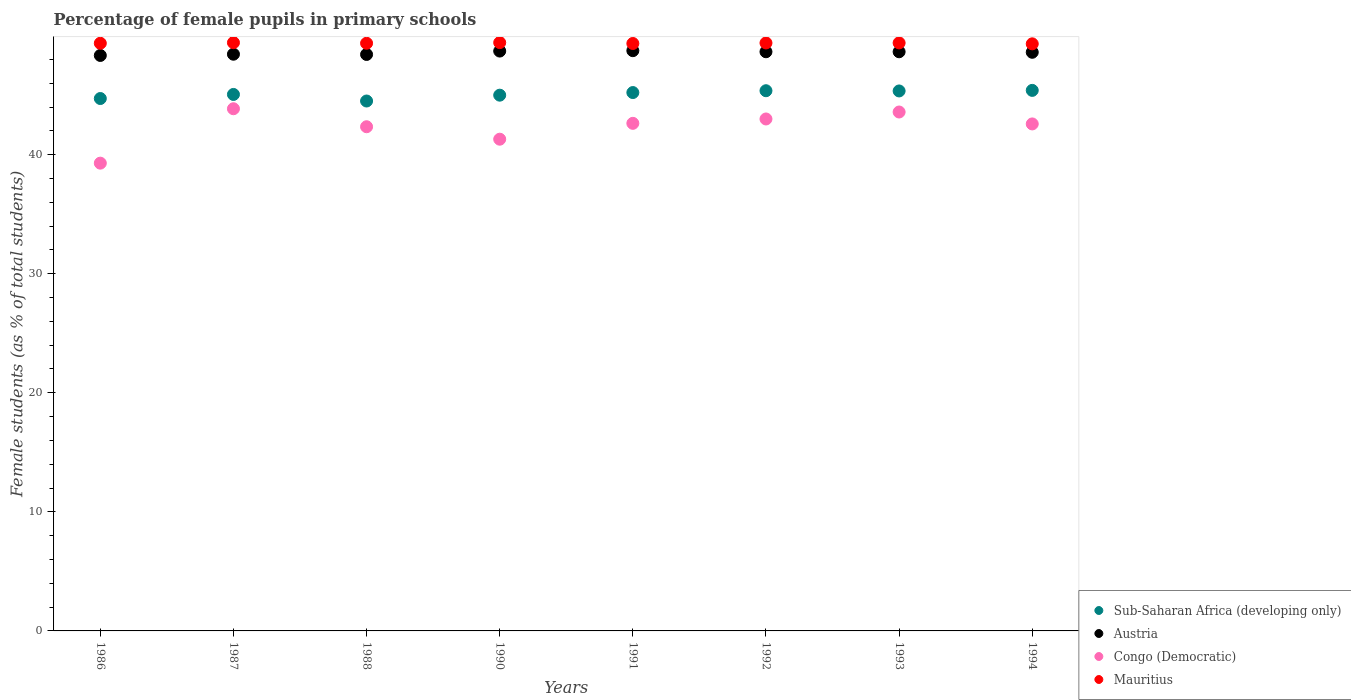Is the number of dotlines equal to the number of legend labels?
Your answer should be very brief. Yes. What is the percentage of female pupils in primary schools in Congo (Democratic) in 1987?
Make the answer very short. 43.86. Across all years, what is the maximum percentage of female pupils in primary schools in Sub-Saharan Africa (developing only)?
Make the answer very short. 45.4. Across all years, what is the minimum percentage of female pupils in primary schools in Congo (Democratic)?
Offer a terse response. 39.29. In which year was the percentage of female pupils in primary schools in Sub-Saharan Africa (developing only) maximum?
Give a very brief answer. 1994. In which year was the percentage of female pupils in primary schools in Austria minimum?
Your answer should be very brief. 1986. What is the total percentage of female pupils in primary schools in Austria in the graph?
Your response must be concise. 388.5. What is the difference between the percentage of female pupils in primary schools in Congo (Democratic) in 1987 and that in 1992?
Offer a very short reply. 0.86. What is the difference between the percentage of female pupils in primary schools in Congo (Democratic) in 1993 and the percentage of female pupils in primary schools in Mauritius in 1987?
Provide a succinct answer. -5.82. What is the average percentage of female pupils in primary schools in Mauritius per year?
Your answer should be very brief. 49.37. In the year 1993, what is the difference between the percentage of female pupils in primary schools in Austria and percentage of female pupils in primary schools in Sub-Saharan Africa (developing only)?
Your answer should be very brief. 3.29. What is the ratio of the percentage of female pupils in primary schools in Sub-Saharan Africa (developing only) in 1987 to that in 1992?
Make the answer very short. 0.99. Is the percentage of female pupils in primary schools in Congo (Democratic) in 1993 less than that in 1994?
Offer a terse response. No. Is the difference between the percentage of female pupils in primary schools in Austria in 1987 and 1990 greater than the difference between the percentage of female pupils in primary schools in Sub-Saharan Africa (developing only) in 1987 and 1990?
Ensure brevity in your answer.  No. What is the difference between the highest and the second highest percentage of female pupils in primary schools in Austria?
Keep it short and to the point. 0.03. What is the difference between the highest and the lowest percentage of female pupils in primary schools in Sub-Saharan Africa (developing only)?
Offer a very short reply. 0.89. In how many years, is the percentage of female pupils in primary schools in Mauritius greater than the average percentage of female pupils in primary schools in Mauritius taken over all years?
Offer a terse response. 4. Is it the case that in every year, the sum of the percentage of female pupils in primary schools in Sub-Saharan Africa (developing only) and percentage of female pupils in primary schools in Mauritius  is greater than the sum of percentage of female pupils in primary schools in Congo (Democratic) and percentage of female pupils in primary schools in Austria?
Make the answer very short. Yes. Is it the case that in every year, the sum of the percentage of female pupils in primary schools in Sub-Saharan Africa (developing only) and percentage of female pupils in primary schools in Austria  is greater than the percentage of female pupils in primary schools in Congo (Democratic)?
Your response must be concise. Yes. Does the percentage of female pupils in primary schools in Sub-Saharan Africa (developing only) monotonically increase over the years?
Your answer should be very brief. No. Is the percentage of female pupils in primary schools in Sub-Saharan Africa (developing only) strictly greater than the percentage of female pupils in primary schools in Mauritius over the years?
Offer a very short reply. No. How many years are there in the graph?
Your answer should be compact. 8. What is the difference between two consecutive major ticks on the Y-axis?
Your answer should be compact. 10. How are the legend labels stacked?
Your answer should be very brief. Vertical. What is the title of the graph?
Offer a very short reply. Percentage of female pupils in primary schools. What is the label or title of the Y-axis?
Give a very brief answer. Female students (as % of total students). What is the Female students (as % of total students) of Sub-Saharan Africa (developing only) in 1986?
Your answer should be compact. 44.71. What is the Female students (as % of total students) in Austria in 1986?
Your answer should be very brief. 48.33. What is the Female students (as % of total students) in Congo (Democratic) in 1986?
Offer a very short reply. 39.29. What is the Female students (as % of total students) in Mauritius in 1986?
Your answer should be compact. 49.36. What is the Female students (as % of total students) in Sub-Saharan Africa (developing only) in 1987?
Offer a very short reply. 45.06. What is the Female students (as % of total students) in Austria in 1987?
Ensure brevity in your answer.  48.44. What is the Female students (as % of total students) of Congo (Democratic) in 1987?
Your answer should be compact. 43.86. What is the Female students (as % of total students) in Mauritius in 1987?
Give a very brief answer. 49.41. What is the Female students (as % of total students) in Sub-Saharan Africa (developing only) in 1988?
Your answer should be compact. 44.51. What is the Female students (as % of total students) of Austria in 1988?
Keep it short and to the point. 48.42. What is the Female students (as % of total students) of Congo (Democratic) in 1988?
Make the answer very short. 42.34. What is the Female students (as % of total students) in Mauritius in 1988?
Ensure brevity in your answer.  49.36. What is the Female students (as % of total students) in Sub-Saharan Africa (developing only) in 1990?
Your response must be concise. 45. What is the Female students (as % of total students) of Austria in 1990?
Provide a short and direct response. 48.7. What is the Female students (as % of total students) of Congo (Democratic) in 1990?
Your answer should be compact. 41.3. What is the Female students (as % of total students) in Mauritius in 1990?
Your response must be concise. 49.41. What is the Female students (as % of total students) of Sub-Saharan Africa (developing only) in 1991?
Your answer should be compact. 45.22. What is the Female students (as % of total students) of Austria in 1991?
Your answer should be compact. 48.73. What is the Female students (as % of total students) in Congo (Democratic) in 1991?
Give a very brief answer. 42.63. What is the Female students (as % of total students) of Mauritius in 1991?
Your response must be concise. 49.34. What is the Female students (as % of total students) in Sub-Saharan Africa (developing only) in 1992?
Your answer should be compact. 45.37. What is the Female students (as % of total students) of Austria in 1992?
Offer a very short reply. 48.64. What is the Female students (as % of total students) in Congo (Democratic) in 1992?
Provide a short and direct response. 43. What is the Female students (as % of total students) of Mauritius in 1992?
Provide a succinct answer. 49.38. What is the Female students (as % of total students) of Sub-Saharan Africa (developing only) in 1993?
Give a very brief answer. 45.35. What is the Female students (as % of total students) of Austria in 1993?
Offer a terse response. 48.64. What is the Female students (as % of total students) of Congo (Democratic) in 1993?
Provide a short and direct response. 43.58. What is the Female students (as % of total students) of Mauritius in 1993?
Your answer should be compact. 49.39. What is the Female students (as % of total students) of Sub-Saharan Africa (developing only) in 1994?
Ensure brevity in your answer.  45.4. What is the Female students (as % of total students) of Austria in 1994?
Offer a terse response. 48.6. What is the Female students (as % of total students) in Congo (Democratic) in 1994?
Provide a succinct answer. 42.58. What is the Female students (as % of total students) in Mauritius in 1994?
Ensure brevity in your answer.  49.31. Across all years, what is the maximum Female students (as % of total students) of Sub-Saharan Africa (developing only)?
Offer a terse response. 45.4. Across all years, what is the maximum Female students (as % of total students) in Austria?
Provide a short and direct response. 48.73. Across all years, what is the maximum Female students (as % of total students) in Congo (Democratic)?
Offer a very short reply. 43.86. Across all years, what is the maximum Female students (as % of total students) of Mauritius?
Your answer should be very brief. 49.41. Across all years, what is the minimum Female students (as % of total students) of Sub-Saharan Africa (developing only)?
Ensure brevity in your answer.  44.51. Across all years, what is the minimum Female students (as % of total students) in Austria?
Offer a terse response. 48.33. Across all years, what is the minimum Female students (as % of total students) in Congo (Democratic)?
Provide a short and direct response. 39.29. Across all years, what is the minimum Female students (as % of total students) in Mauritius?
Offer a very short reply. 49.31. What is the total Female students (as % of total students) in Sub-Saharan Africa (developing only) in the graph?
Provide a short and direct response. 360.61. What is the total Female students (as % of total students) in Austria in the graph?
Offer a terse response. 388.5. What is the total Female students (as % of total students) of Congo (Democratic) in the graph?
Offer a very short reply. 338.57. What is the total Female students (as % of total students) in Mauritius in the graph?
Ensure brevity in your answer.  394.94. What is the difference between the Female students (as % of total students) of Sub-Saharan Africa (developing only) in 1986 and that in 1987?
Your answer should be compact. -0.34. What is the difference between the Female students (as % of total students) of Austria in 1986 and that in 1987?
Offer a terse response. -0.1. What is the difference between the Female students (as % of total students) in Congo (Democratic) in 1986 and that in 1987?
Your answer should be compact. -4.57. What is the difference between the Female students (as % of total students) of Mauritius in 1986 and that in 1987?
Your answer should be very brief. -0.05. What is the difference between the Female students (as % of total students) in Sub-Saharan Africa (developing only) in 1986 and that in 1988?
Ensure brevity in your answer.  0.21. What is the difference between the Female students (as % of total students) in Austria in 1986 and that in 1988?
Provide a succinct answer. -0.08. What is the difference between the Female students (as % of total students) of Congo (Democratic) in 1986 and that in 1988?
Offer a very short reply. -3.06. What is the difference between the Female students (as % of total students) in Mauritius in 1986 and that in 1988?
Your answer should be very brief. -0. What is the difference between the Female students (as % of total students) of Sub-Saharan Africa (developing only) in 1986 and that in 1990?
Ensure brevity in your answer.  -0.28. What is the difference between the Female students (as % of total students) in Austria in 1986 and that in 1990?
Make the answer very short. -0.37. What is the difference between the Female students (as % of total students) of Congo (Democratic) in 1986 and that in 1990?
Offer a very short reply. -2.01. What is the difference between the Female students (as % of total students) in Mauritius in 1986 and that in 1990?
Your answer should be very brief. -0.06. What is the difference between the Female students (as % of total students) in Sub-Saharan Africa (developing only) in 1986 and that in 1991?
Offer a very short reply. -0.5. What is the difference between the Female students (as % of total students) of Austria in 1986 and that in 1991?
Give a very brief answer. -0.4. What is the difference between the Female students (as % of total students) in Congo (Democratic) in 1986 and that in 1991?
Your answer should be very brief. -3.34. What is the difference between the Female students (as % of total students) in Mauritius in 1986 and that in 1991?
Offer a very short reply. 0.02. What is the difference between the Female students (as % of total students) of Sub-Saharan Africa (developing only) in 1986 and that in 1992?
Your answer should be very brief. -0.66. What is the difference between the Female students (as % of total students) of Austria in 1986 and that in 1992?
Ensure brevity in your answer.  -0.31. What is the difference between the Female students (as % of total students) of Congo (Democratic) in 1986 and that in 1992?
Your response must be concise. -3.71. What is the difference between the Female students (as % of total students) of Mauritius in 1986 and that in 1992?
Keep it short and to the point. -0.03. What is the difference between the Female students (as % of total students) in Sub-Saharan Africa (developing only) in 1986 and that in 1993?
Offer a terse response. -0.64. What is the difference between the Female students (as % of total students) in Austria in 1986 and that in 1993?
Ensure brevity in your answer.  -0.31. What is the difference between the Female students (as % of total students) in Congo (Democratic) in 1986 and that in 1993?
Your answer should be compact. -4.3. What is the difference between the Female students (as % of total students) of Mauritius in 1986 and that in 1993?
Your answer should be compact. -0.03. What is the difference between the Female students (as % of total students) of Sub-Saharan Africa (developing only) in 1986 and that in 1994?
Provide a succinct answer. -0.68. What is the difference between the Female students (as % of total students) in Austria in 1986 and that in 1994?
Make the answer very short. -0.27. What is the difference between the Female students (as % of total students) in Congo (Democratic) in 1986 and that in 1994?
Offer a terse response. -3.29. What is the difference between the Female students (as % of total students) of Mauritius in 1986 and that in 1994?
Your response must be concise. 0.05. What is the difference between the Female students (as % of total students) in Sub-Saharan Africa (developing only) in 1987 and that in 1988?
Offer a terse response. 0.55. What is the difference between the Female students (as % of total students) of Austria in 1987 and that in 1988?
Keep it short and to the point. 0.02. What is the difference between the Female students (as % of total students) in Congo (Democratic) in 1987 and that in 1988?
Your answer should be compact. 1.51. What is the difference between the Female students (as % of total students) in Mauritius in 1987 and that in 1988?
Offer a terse response. 0.05. What is the difference between the Female students (as % of total students) in Sub-Saharan Africa (developing only) in 1987 and that in 1990?
Ensure brevity in your answer.  0.06. What is the difference between the Female students (as % of total students) in Austria in 1987 and that in 1990?
Your answer should be very brief. -0.26. What is the difference between the Female students (as % of total students) of Congo (Democratic) in 1987 and that in 1990?
Provide a succinct answer. 2.56. What is the difference between the Female students (as % of total students) of Mauritius in 1987 and that in 1990?
Provide a short and direct response. -0. What is the difference between the Female students (as % of total students) of Sub-Saharan Africa (developing only) in 1987 and that in 1991?
Offer a terse response. -0.16. What is the difference between the Female students (as % of total students) in Austria in 1987 and that in 1991?
Your answer should be compact. -0.3. What is the difference between the Female students (as % of total students) in Congo (Democratic) in 1987 and that in 1991?
Provide a succinct answer. 1.23. What is the difference between the Female students (as % of total students) of Mauritius in 1987 and that in 1991?
Provide a succinct answer. 0.07. What is the difference between the Female students (as % of total students) in Sub-Saharan Africa (developing only) in 1987 and that in 1992?
Offer a very short reply. -0.31. What is the difference between the Female students (as % of total students) in Austria in 1987 and that in 1992?
Provide a short and direct response. -0.21. What is the difference between the Female students (as % of total students) in Congo (Democratic) in 1987 and that in 1992?
Provide a short and direct response. 0.86. What is the difference between the Female students (as % of total students) of Mauritius in 1987 and that in 1992?
Your answer should be very brief. 0.03. What is the difference between the Female students (as % of total students) in Sub-Saharan Africa (developing only) in 1987 and that in 1993?
Provide a succinct answer. -0.29. What is the difference between the Female students (as % of total students) of Austria in 1987 and that in 1993?
Offer a terse response. -0.21. What is the difference between the Female students (as % of total students) of Congo (Democratic) in 1987 and that in 1993?
Your answer should be very brief. 0.27. What is the difference between the Female students (as % of total students) of Mauritius in 1987 and that in 1993?
Your answer should be compact. 0.02. What is the difference between the Female students (as % of total students) of Sub-Saharan Africa (developing only) in 1987 and that in 1994?
Make the answer very short. -0.34. What is the difference between the Female students (as % of total students) of Austria in 1987 and that in 1994?
Provide a succinct answer. -0.16. What is the difference between the Female students (as % of total students) in Congo (Democratic) in 1987 and that in 1994?
Give a very brief answer. 1.27. What is the difference between the Female students (as % of total students) of Mauritius in 1987 and that in 1994?
Your answer should be compact. 0.1. What is the difference between the Female students (as % of total students) in Sub-Saharan Africa (developing only) in 1988 and that in 1990?
Your answer should be very brief. -0.49. What is the difference between the Female students (as % of total students) in Austria in 1988 and that in 1990?
Keep it short and to the point. -0.28. What is the difference between the Female students (as % of total students) of Congo (Democratic) in 1988 and that in 1990?
Offer a very short reply. 1.05. What is the difference between the Female students (as % of total students) in Mauritius in 1988 and that in 1990?
Offer a very short reply. -0.05. What is the difference between the Female students (as % of total students) of Sub-Saharan Africa (developing only) in 1988 and that in 1991?
Keep it short and to the point. -0.71. What is the difference between the Female students (as % of total students) of Austria in 1988 and that in 1991?
Your answer should be compact. -0.32. What is the difference between the Female students (as % of total students) in Congo (Democratic) in 1988 and that in 1991?
Your response must be concise. -0.29. What is the difference between the Female students (as % of total students) in Mauritius in 1988 and that in 1991?
Offer a very short reply. 0.02. What is the difference between the Female students (as % of total students) in Sub-Saharan Africa (developing only) in 1988 and that in 1992?
Provide a short and direct response. -0.86. What is the difference between the Female students (as % of total students) in Austria in 1988 and that in 1992?
Provide a short and direct response. -0.23. What is the difference between the Female students (as % of total students) in Congo (Democratic) in 1988 and that in 1992?
Your response must be concise. -0.65. What is the difference between the Female students (as % of total students) of Mauritius in 1988 and that in 1992?
Provide a succinct answer. -0.02. What is the difference between the Female students (as % of total students) of Sub-Saharan Africa (developing only) in 1988 and that in 1993?
Your answer should be very brief. -0.84. What is the difference between the Female students (as % of total students) in Austria in 1988 and that in 1993?
Your response must be concise. -0.23. What is the difference between the Female students (as % of total students) of Congo (Democratic) in 1988 and that in 1993?
Your answer should be very brief. -1.24. What is the difference between the Female students (as % of total students) of Mauritius in 1988 and that in 1993?
Give a very brief answer. -0.03. What is the difference between the Female students (as % of total students) in Sub-Saharan Africa (developing only) in 1988 and that in 1994?
Make the answer very short. -0.89. What is the difference between the Female students (as % of total students) of Austria in 1988 and that in 1994?
Keep it short and to the point. -0.18. What is the difference between the Female students (as % of total students) of Congo (Democratic) in 1988 and that in 1994?
Give a very brief answer. -0.24. What is the difference between the Female students (as % of total students) in Mauritius in 1988 and that in 1994?
Offer a very short reply. 0.05. What is the difference between the Female students (as % of total students) in Sub-Saharan Africa (developing only) in 1990 and that in 1991?
Provide a succinct answer. -0.22. What is the difference between the Female students (as % of total students) in Austria in 1990 and that in 1991?
Keep it short and to the point. -0.03. What is the difference between the Female students (as % of total students) of Congo (Democratic) in 1990 and that in 1991?
Provide a short and direct response. -1.33. What is the difference between the Female students (as % of total students) of Mauritius in 1990 and that in 1991?
Your response must be concise. 0.07. What is the difference between the Female students (as % of total students) in Sub-Saharan Africa (developing only) in 1990 and that in 1992?
Keep it short and to the point. -0.37. What is the difference between the Female students (as % of total students) of Austria in 1990 and that in 1992?
Make the answer very short. 0.06. What is the difference between the Female students (as % of total students) of Congo (Democratic) in 1990 and that in 1992?
Offer a very short reply. -1.7. What is the difference between the Female students (as % of total students) of Mauritius in 1990 and that in 1992?
Provide a short and direct response. 0.03. What is the difference between the Female students (as % of total students) of Sub-Saharan Africa (developing only) in 1990 and that in 1993?
Your response must be concise. -0.35. What is the difference between the Female students (as % of total students) of Austria in 1990 and that in 1993?
Offer a very short reply. 0.06. What is the difference between the Female students (as % of total students) of Congo (Democratic) in 1990 and that in 1993?
Offer a very short reply. -2.28. What is the difference between the Female students (as % of total students) of Mauritius in 1990 and that in 1993?
Your answer should be compact. 0.03. What is the difference between the Female students (as % of total students) of Sub-Saharan Africa (developing only) in 1990 and that in 1994?
Provide a succinct answer. -0.4. What is the difference between the Female students (as % of total students) in Austria in 1990 and that in 1994?
Provide a succinct answer. 0.1. What is the difference between the Female students (as % of total students) of Congo (Democratic) in 1990 and that in 1994?
Your response must be concise. -1.28. What is the difference between the Female students (as % of total students) of Mauritius in 1990 and that in 1994?
Offer a very short reply. 0.1. What is the difference between the Female students (as % of total students) in Sub-Saharan Africa (developing only) in 1991 and that in 1992?
Provide a succinct answer. -0.15. What is the difference between the Female students (as % of total students) of Austria in 1991 and that in 1992?
Your response must be concise. 0.09. What is the difference between the Female students (as % of total students) in Congo (Democratic) in 1991 and that in 1992?
Provide a succinct answer. -0.37. What is the difference between the Female students (as % of total students) in Mauritius in 1991 and that in 1992?
Ensure brevity in your answer.  -0.04. What is the difference between the Female students (as % of total students) of Sub-Saharan Africa (developing only) in 1991 and that in 1993?
Offer a terse response. -0.13. What is the difference between the Female students (as % of total students) in Austria in 1991 and that in 1993?
Your answer should be very brief. 0.09. What is the difference between the Female students (as % of total students) of Congo (Democratic) in 1991 and that in 1993?
Your answer should be compact. -0.95. What is the difference between the Female students (as % of total students) in Mauritius in 1991 and that in 1993?
Offer a very short reply. -0.05. What is the difference between the Female students (as % of total students) of Sub-Saharan Africa (developing only) in 1991 and that in 1994?
Offer a very short reply. -0.18. What is the difference between the Female students (as % of total students) in Austria in 1991 and that in 1994?
Keep it short and to the point. 0.14. What is the difference between the Female students (as % of total students) of Congo (Democratic) in 1991 and that in 1994?
Provide a succinct answer. 0.05. What is the difference between the Female students (as % of total students) in Mauritius in 1991 and that in 1994?
Your answer should be very brief. 0.03. What is the difference between the Female students (as % of total students) of Sub-Saharan Africa (developing only) in 1992 and that in 1993?
Give a very brief answer. 0.02. What is the difference between the Female students (as % of total students) in Congo (Democratic) in 1992 and that in 1993?
Your answer should be very brief. -0.58. What is the difference between the Female students (as % of total students) of Mauritius in 1992 and that in 1993?
Give a very brief answer. -0. What is the difference between the Female students (as % of total students) in Sub-Saharan Africa (developing only) in 1992 and that in 1994?
Keep it short and to the point. -0.03. What is the difference between the Female students (as % of total students) in Austria in 1992 and that in 1994?
Keep it short and to the point. 0.04. What is the difference between the Female students (as % of total students) of Congo (Democratic) in 1992 and that in 1994?
Ensure brevity in your answer.  0.42. What is the difference between the Female students (as % of total students) of Mauritius in 1992 and that in 1994?
Ensure brevity in your answer.  0.07. What is the difference between the Female students (as % of total students) of Sub-Saharan Africa (developing only) in 1993 and that in 1994?
Your answer should be compact. -0.05. What is the difference between the Female students (as % of total students) of Austria in 1993 and that in 1994?
Ensure brevity in your answer.  0.04. What is the difference between the Female students (as % of total students) of Mauritius in 1993 and that in 1994?
Your answer should be very brief. 0.08. What is the difference between the Female students (as % of total students) of Sub-Saharan Africa (developing only) in 1986 and the Female students (as % of total students) of Austria in 1987?
Keep it short and to the point. -3.72. What is the difference between the Female students (as % of total students) of Sub-Saharan Africa (developing only) in 1986 and the Female students (as % of total students) of Congo (Democratic) in 1987?
Provide a succinct answer. 0.86. What is the difference between the Female students (as % of total students) in Sub-Saharan Africa (developing only) in 1986 and the Female students (as % of total students) in Mauritius in 1987?
Provide a succinct answer. -4.69. What is the difference between the Female students (as % of total students) of Austria in 1986 and the Female students (as % of total students) of Congo (Democratic) in 1987?
Offer a terse response. 4.48. What is the difference between the Female students (as % of total students) in Austria in 1986 and the Female students (as % of total students) in Mauritius in 1987?
Keep it short and to the point. -1.07. What is the difference between the Female students (as % of total students) of Congo (Democratic) in 1986 and the Female students (as % of total students) of Mauritius in 1987?
Give a very brief answer. -10.12. What is the difference between the Female students (as % of total students) in Sub-Saharan Africa (developing only) in 1986 and the Female students (as % of total students) in Austria in 1988?
Make the answer very short. -3.7. What is the difference between the Female students (as % of total students) of Sub-Saharan Africa (developing only) in 1986 and the Female students (as % of total students) of Congo (Democratic) in 1988?
Ensure brevity in your answer.  2.37. What is the difference between the Female students (as % of total students) in Sub-Saharan Africa (developing only) in 1986 and the Female students (as % of total students) in Mauritius in 1988?
Your answer should be compact. -4.64. What is the difference between the Female students (as % of total students) in Austria in 1986 and the Female students (as % of total students) in Congo (Democratic) in 1988?
Offer a very short reply. 5.99. What is the difference between the Female students (as % of total students) in Austria in 1986 and the Female students (as % of total students) in Mauritius in 1988?
Your answer should be very brief. -1.02. What is the difference between the Female students (as % of total students) of Congo (Democratic) in 1986 and the Female students (as % of total students) of Mauritius in 1988?
Keep it short and to the point. -10.07. What is the difference between the Female students (as % of total students) of Sub-Saharan Africa (developing only) in 1986 and the Female students (as % of total students) of Austria in 1990?
Provide a short and direct response. -3.99. What is the difference between the Female students (as % of total students) in Sub-Saharan Africa (developing only) in 1986 and the Female students (as % of total students) in Congo (Democratic) in 1990?
Make the answer very short. 3.42. What is the difference between the Female students (as % of total students) in Sub-Saharan Africa (developing only) in 1986 and the Female students (as % of total students) in Mauritius in 1990?
Give a very brief answer. -4.7. What is the difference between the Female students (as % of total students) of Austria in 1986 and the Female students (as % of total students) of Congo (Democratic) in 1990?
Give a very brief answer. 7.03. What is the difference between the Female students (as % of total students) in Austria in 1986 and the Female students (as % of total students) in Mauritius in 1990?
Provide a succinct answer. -1.08. What is the difference between the Female students (as % of total students) in Congo (Democratic) in 1986 and the Female students (as % of total students) in Mauritius in 1990?
Your response must be concise. -10.12. What is the difference between the Female students (as % of total students) of Sub-Saharan Africa (developing only) in 1986 and the Female students (as % of total students) of Austria in 1991?
Provide a short and direct response. -4.02. What is the difference between the Female students (as % of total students) of Sub-Saharan Africa (developing only) in 1986 and the Female students (as % of total students) of Congo (Democratic) in 1991?
Offer a very short reply. 2.08. What is the difference between the Female students (as % of total students) in Sub-Saharan Africa (developing only) in 1986 and the Female students (as % of total students) in Mauritius in 1991?
Give a very brief answer. -4.62. What is the difference between the Female students (as % of total students) in Austria in 1986 and the Female students (as % of total students) in Congo (Democratic) in 1991?
Make the answer very short. 5.7. What is the difference between the Female students (as % of total students) in Austria in 1986 and the Female students (as % of total students) in Mauritius in 1991?
Your response must be concise. -1.01. What is the difference between the Female students (as % of total students) in Congo (Democratic) in 1986 and the Female students (as % of total students) in Mauritius in 1991?
Provide a succinct answer. -10.05. What is the difference between the Female students (as % of total students) in Sub-Saharan Africa (developing only) in 1986 and the Female students (as % of total students) in Austria in 1992?
Provide a succinct answer. -3.93. What is the difference between the Female students (as % of total students) in Sub-Saharan Africa (developing only) in 1986 and the Female students (as % of total students) in Congo (Democratic) in 1992?
Offer a very short reply. 1.72. What is the difference between the Female students (as % of total students) of Sub-Saharan Africa (developing only) in 1986 and the Female students (as % of total students) of Mauritius in 1992?
Offer a terse response. -4.67. What is the difference between the Female students (as % of total students) in Austria in 1986 and the Female students (as % of total students) in Congo (Democratic) in 1992?
Provide a succinct answer. 5.33. What is the difference between the Female students (as % of total students) in Austria in 1986 and the Female students (as % of total students) in Mauritius in 1992?
Ensure brevity in your answer.  -1.05. What is the difference between the Female students (as % of total students) of Congo (Democratic) in 1986 and the Female students (as % of total students) of Mauritius in 1992?
Provide a succinct answer. -10.09. What is the difference between the Female students (as % of total students) of Sub-Saharan Africa (developing only) in 1986 and the Female students (as % of total students) of Austria in 1993?
Ensure brevity in your answer.  -3.93. What is the difference between the Female students (as % of total students) of Sub-Saharan Africa (developing only) in 1986 and the Female students (as % of total students) of Congo (Democratic) in 1993?
Make the answer very short. 1.13. What is the difference between the Female students (as % of total students) in Sub-Saharan Africa (developing only) in 1986 and the Female students (as % of total students) in Mauritius in 1993?
Offer a very short reply. -4.67. What is the difference between the Female students (as % of total students) of Austria in 1986 and the Female students (as % of total students) of Congo (Democratic) in 1993?
Make the answer very short. 4.75. What is the difference between the Female students (as % of total students) in Austria in 1986 and the Female students (as % of total students) in Mauritius in 1993?
Provide a succinct answer. -1.05. What is the difference between the Female students (as % of total students) in Congo (Democratic) in 1986 and the Female students (as % of total students) in Mauritius in 1993?
Give a very brief answer. -10.1. What is the difference between the Female students (as % of total students) in Sub-Saharan Africa (developing only) in 1986 and the Female students (as % of total students) in Austria in 1994?
Provide a succinct answer. -3.88. What is the difference between the Female students (as % of total students) of Sub-Saharan Africa (developing only) in 1986 and the Female students (as % of total students) of Congo (Democratic) in 1994?
Offer a very short reply. 2.13. What is the difference between the Female students (as % of total students) of Sub-Saharan Africa (developing only) in 1986 and the Female students (as % of total students) of Mauritius in 1994?
Make the answer very short. -4.59. What is the difference between the Female students (as % of total students) of Austria in 1986 and the Female students (as % of total students) of Congo (Democratic) in 1994?
Your response must be concise. 5.75. What is the difference between the Female students (as % of total students) in Austria in 1986 and the Female students (as % of total students) in Mauritius in 1994?
Provide a succinct answer. -0.98. What is the difference between the Female students (as % of total students) in Congo (Democratic) in 1986 and the Female students (as % of total students) in Mauritius in 1994?
Keep it short and to the point. -10.02. What is the difference between the Female students (as % of total students) in Sub-Saharan Africa (developing only) in 1987 and the Female students (as % of total students) in Austria in 1988?
Ensure brevity in your answer.  -3.36. What is the difference between the Female students (as % of total students) in Sub-Saharan Africa (developing only) in 1987 and the Female students (as % of total students) in Congo (Democratic) in 1988?
Your response must be concise. 2.71. What is the difference between the Female students (as % of total students) in Sub-Saharan Africa (developing only) in 1987 and the Female students (as % of total students) in Mauritius in 1988?
Your answer should be compact. -4.3. What is the difference between the Female students (as % of total students) in Austria in 1987 and the Female students (as % of total students) in Congo (Democratic) in 1988?
Offer a very short reply. 6.09. What is the difference between the Female students (as % of total students) of Austria in 1987 and the Female students (as % of total students) of Mauritius in 1988?
Your answer should be very brief. -0.92. What is the difference between the Female students (as % of total students) of Congo (Democratic) in 1987 and the Female students (as % of total students) of Mauritius in 1988?
Keep it short and to the point. -5.5. What is the difference between the Female students (as % of total students) of Sub-Saharan Africa (developing only) in 1987 and the Female students (as % of total students) of Austria in 1990?
Your answer should be compact. -3.64. What is the difference between the Female students (as % of total students) of Sub-Saharan Africa (developing only) in 1987 and the Female students (as % of total students) of Congo (Democratic) in 1990?
Provide a short and direct response. 3.76. What is the difference between the Female students (as % of total students) in Sub-Saharan Africa (developing only) in 1987 and the Female students (as % of total students) in Mauritius in 1990?
Provide a succinct answer. -4.35. What is the difference between the Female students (as % of total students) in Austria in 1987 and the Female students (as % of total students) in Congo (Democratic) in 1990?
Your answer should be very brief. 7.14. What is the difference between the Female students (as % of total students) in Austria in 1987 and the Female students (as % of total students) in Mauritius in 1990?
Offer a very short reply. -0.97. What is the difference between the Female students (as % of total students) of Congo (Democratic) in 1987 and the Female students (as % of total students) of Mauritius in 1990?
Provide a succinct answer. -5.56. What is the difference between the Female students (as % of total students) in Sub-Saharan Africa (developing only) in 1987 and the Female students (as % of total students) in Austria in 1991?
Ensure brevity in your answer.  -3.68. What is the difference between the Female students (as % of total students) in Sub-Saharan Africa (developing only) in 1987 and the Female students (as % of total students) in Congo (Democratic) in 1991?
Give a very brief answer. 2.43. What is the difference between the Female students (as % of total students) of Sub-Saharan Africa (developing only) in 1987 and the Female students (as % of total students) of Mauritius in 1991?
Ensure brevity in your answer.  -4.28. What is the difference between the Female students (as % of total students) of Austria in 1987 and the Female students (as % of total students) of Congo (Democratic) in 1991?
Your answer should be compact. 5.81. What is the difference between the Female students (as % of total students) of Austria in 1987 and the Female students (as % of total students) of Mauritius in 1991?
Your answer should be compact. -0.9. What is the difference between the Female students (as % of total students) of Congo (Democratic) in 1987 and the Female students (as % of total students) of Mauritius in 1991?
Offer a terse response. -5.48. What is the difference between the Female students (as % of total students) in Sub-Saharan Africa (developing only) in 1987 and the Female students (as % of total students) in Austria in 1992?
Your response must be concise. -3.58. What is the difference between the Female students (as % of total students) of Sub-Saharan Africa (developing only) in 1987 and the Female students (as % of total students) of Congo (Democratic) in 1992?
Offer a very short reply. 2.06. What is the difference between the Female students (as % of total students) in Sub-Saharan Africa (developing only) in 1987 and the Female students (as % of total students) in Mauritius in 1992?
Make the answer very short. -4.32. What is the difference between the Female students (as % of total students) in Austria in 1987 and the Female students (as % of total students) in Congo (Democratic) in 1992?
Make the answer very short. 5.44. What is the difference between the Female students (as % of total students) in Austria in 1987 and the Female students (as % of total students) in Mauritius in 1992?
Provide a short and direct response. -0.94. What is the difference between the Female students (as % of total students) in Congo (Democratic) in 1987 and the Female students (as % of total students) in Mauritius in 1992?
Provide a short and direct response. -5.53. What is the difference between the Female students (as % of total students) in Sub-Saharan Africa (developing only) in 1987 and the Female students (as % of total students) in Austria in 1993?
Your answer should be compact. -3.58. What is the difference between the Female students (as % of total students) of Sub-Saharan Africa (developing only) in 1987 and the Female students (as % of total students) of Congo (Democratic) in 1993?
Your answer should be very brief. 1.48. What is the difference between the Female students (as % of total students) in Sub-Saharan Africa (developing only) in 1987 and the Female students (as % of total students) in Mauritius in 1993?
Give a very brief answer. -4.33. What is the difference between the Female students (as % of total students) of Austria in 1987 and the Female students (as % of total students) of Congo (Democratic) in 1993?
Provide a succinct answer. 4.85. What is the difference between the Female students (as % of total students) of Austria in 1987 and the Female students (as % of total students) of Mauritius in 1993?
Offer a very short reply. -0.95. What is the difference between the Female students (as % of total students) of Congo (Democratic) in 1987 and the Female students (as % of total students) of Mauritius in 1993?
Give a very brief answer. -5.53. What is the difference between the Female students (as % of total students) of Sub-Saharan Africa (developing only) in 1987 and the Female students (as % of total students) of Austria in 1994?
Provide a succinct answer. -3.54. What is the difference between the Female students (as % of total students) in Sub-Saharan Africa (developing only) in 1987 and the Female students (as % of total students) in Congo (Democratic) in 1994?
Offer a very short reply. 2.48. What is the difference between the Female students (as % of total students) of Sub-Saharan Africa (developing only) in 1987 and the Female students (as % of total students) of Mauritius in 1994?
Ensure brevity in your answer.  -4.25. What is the difference between the Female students (as % of total students) in Austria in 1987 and the Female students (as % of total students) in Congo (Democratic) in 1994?
Offer a terse response. 5.86. What is the difference between the Female students (as % of total students) of Austria in 1987 and the Female students (as % of total students) of Mauritius in 1994?
Keep it short and to the point. -0.87. What is the difference between the Female students (as % of total students) in Congo (Democratic) in 1987 and the Female students (as % of total students) in Mauritius in 1994?
Your answer should be compact. -5.45. What is the difference between the Female students (as % of total students) of Sub-Saharan Africa (developing only) in 1988 and the Female students (as % of total students) of Austria in 1990?
Your answer should be very brief. -4.19. What is the difference between the Female students (as % of total students) in Sub-Saharan Africa (developing only) in 1988 and the Female students (as % of total students) in Congo (Democratic) in 1990?
Keep it short and to the point. 3.21. What is the difference between the Female students (as % of total students) of Sub-Saharan Africa (developing only) in 1988 and the Female students (as % of total students) of Mauritius in 1990?
Make the answer very short. -4.91. What is the difference between the Female students (as % of total students) in Austria in 1988 and the Female students (as % of total students) in Congo (Democratic) in 1990?
Give a very brief answer. 7.12. What is the difference between the Female students (as % of total students) of Austria in 1988 and the Female students (as % of total students) of Mauritius in 1990?
Your response must be concise. -1. What is the difference between the Female students (as % of total students) in Congo (Democratic) in 1988 and the Female students (as % of total students) in Mauritius in 1990?
Keep it short and to the point. -7.07. What is the difference between the Female students (as % of total students) in Sub-Saharan Africa (developing only) in 1988 and the Female students (as % of total students) in Austria in 1991?
Ensure brevity in your answer.  -4.23. What is the difference between the Female students (as % of total students) in Sub-Saharan Africa (developing only) in 1988 and the Female students (as % of total students) in Congo (Democratic) in 1991?
Your response must be concise. 1.88. What is the difference between the Female students (as % of total students) of Sub-Saharan Africa (developing only) in 1988 and the Female students (as % of total students) of Mauritius in 1991?
Provide a succinct answer. -4.83. What is the difference between the Female students (as % of total students) in Austria in 1988 and the Female students (as % of total students) in Congo (Democratic) in 1991?
Give a very brief answer. 5.79. What is the difference between the Female students (as % of total students) of Austria in 1988 and the Female students (as % of total students) of Mauritius in 1991?
Offer a very short reply. -0.92. What is the difference between the Female students (as % of total students) in Congo (Democratic) in 1988 and the Female students (as % of total students) in Mauritius in 1991?
Make the answer very short. -6.99. What is the difference between the Female students (as % of total students) in Sub-Saharan Africa (developing only) in 1988 and the Female students (as % of total students) in Austria in 1992?
Provide a short and direct response. -4.14. What is the difference between the Female students (as % of total students) in Sub-Saharan Africa (developing only) in 1988 and the Female students (as % of total students) in Congo (Democratic) in 1992?
Provide a short and direct response. 1.51. What is the difference between the Female students (as % of total students) in Sub-Saharan Africa (developing only) in 1988 and the Female students (as % of total students) in Mauritius in 1992?
Provide a succinct answer. -4.88. What is the difference between the Female students (as % of total students) in Austria in 1988 and the Female students (as % of total students) in Congo (Democratic) in 1992?
Give a very brief answer. 5.42. What is the difference between the Female students (as % of total students) of Austria in 1988 and the Female students (as % of total students) of Mauritius in 1992?
Your answer should be compact. -0.97. What is the difference between the Female students (as % of total students) of Congo (Democratic) in 1988 and the Female students (as % of total students) of Mauritius in 1992?
Provide a short and direct response. -7.04. What is the difference between the Female students (as % of total students) in Sub-Saharan Africa (developing only) in 1988 and the Female students (as % of total students) in Austria in 1993?
Ensure brevity in your answer.  -4.14. What is the difference between the Female students (as % of total students) of Sub-Saharan Africa (developing only) in 1988 and the Female students (as % of total students) of Congo (Democratic) in 1993?
Your answer should be compact. 0.92. What is the difference between the Female students (as % of total students) in Sub-Saharan Africa (developing only) in 1988 and the Female students (as % of total students) in Mauritius in 1993?
Ensure brevity in your answer.  -4.88. What is the difference between the Female students (as % of total students) of Austria in 1988 and the Female students (as % of total students) of Congo (Democratic) in 1993?
Keep it short and to the point. 4.83. What is the difference between the Female students (as % of total students) of Austria in 1988 and the Female students (as % of total students) of Mauritius in 1993?
Your answer should be very brief. -0.97. What is the difference between the Female students (as % of total students) in Congo (Democratic) in 1988 and the Female students (as % of total students) in Mauritius in 1993?
Your response must be concise. -7.04. What is the difference between the Female students (as % of total students) in Sub-Saharan Africa (developing only) in 1988 and the Female students (as % of total students) in Austria in 1994?
Offer a very short reply. -4.09. What is the difference between the Female students (as % of total students) in Sub-Saharan Africa (developing only) in 1988 and the Female students (as % of total students) in Congo (Democratic) in 1994?
Ensure brevity in your answer.  1.92. What is the difference between the Female students (as % of total students) in Sub-Saharan Africa (developing only) in 1988 and the Female students (as % of total students) in Mauritius in 1994?
Offer a terse response. -4.8. What is the difference between the Female students (as % of total students) in Austria in 1988 and the Female students (as % of total students) in Congo (Democratic) in 1994?
Your answer should be compact. 5.83. What is the difference between the Female students (as % of total students) in Austria in 1988 and the Female students (as % of total students) in Mauritius in 1994?
Provide a short and direct response. -0.89. What is the difference between the Female students (as % of total students) in Congo (Democratic) in 1988 and the Female students (as % of total students) in Mauritius in 1994?
Provide a succinct answer. -6.96. What is the difference between the Female students (as % of total students) of Sub-Saharan Africa (developing only) in 1990 and the Female students (as % of total students) of Austria in 1991?
Ensure brevity in your answer.  -3.74. What is the difference between the Female students (as % of total students) of Sub-Saharan Africa (developing only) in 1990 and the Female students (as % of total students) of Congo (Democratic) in 1991?
Make the answer very short. 2.37. What is the difference between the Female students (as % of total students) in Sub-Saharan Africa (developing only) in 1990 and the Female students (as % of total students) in Mauritius in 1991?
Offer a very short reply. -4.34. What is the difference between the Female students (as % of total students) of Austria in 1990 and the Female students (as % of total students) of Congo (Democratic) in 1991?
Offer a terse response. 6.07. What is the difference between the Female students (as % of total students) in Austria in 1990 and the Female students (as % of total students) in Mauritius in 1991?
Provide a short and direct response. -0.64. What is the difference between the Female students (as % of total students) of Congo (Democratic) in 1990 and the Female students (as % of total students) of Mauritius in 1991?
Provide a succinct answer. -8.04. What is the difference between the Female students (as % of total students) in Sub-Saharan Africa (developing only) in 1990 and the Female students (as % of total students) in Austria in 1992?
Keep it short and to the point. -3.65. What is the difference between the Female students (as % of total students) of Sub-Saharan Africa (developing only) in 1990 and the Female students (as % of total students) of Congo (Democratic) in 1992?
Provide a succinct answer. 2. What is the difference between the Female students (as % of total students) of Sub-Saharan Africa (developing only) in 1990 and the Female students (as % of total students) of Mauritius in 1992?
Give a very brief answer. -4.39. What is the difference between the Female students (as % of total students) of Austria in 1990 and the Female students (as % of total students) of Congo (Democratic) in 1992?
Keep it short and to the point. 5.7. What is the difference between the Female students (as % of total students) of Austria in 1990 and the Female students (as % of total students) of Mauritius in 1992?
Give a very brief answer. -0.68. What is the difference between the Female students (as % of total students) in Congo (Democratic) in 1990 and the Female students (as % of total students) in Mauritius in 1992?
Make the answer very short. -8.08. What is the difference between the Female students (as % of total students) in Sub-Saharan Africa (developing only) in 1990 and the Female students (as % of total students) in Austria in 1993?
Provide a short and direct response. -3.65. What is the difference between the Female students (as % of total students) in Sub-Saharan Africa (developing only) in 1990 and the Female students (as % of total students) in Congo (Democratic) in 1993?
Offer a terse response. 1.41. What is the difference between the Female students (as % of total students) in Sub-Saharan Africa (developing only) in 1990 and the Female students (as % of total students) in Mauritius in 1993?
Your answer should be compact. -4.39. What is the difference between the Female students (as % of total students) of Austria in 1990 and the Female students (as % of total students) of Congo (Democratic) in 1993?
Your answer should be very brief. 5.12. What is the difference between the Female students (as % of total students) in Austria in 1990 and the Female students (as % of total students) in Mauritius in 1993?
Your answer should be compact. -0.69. What is the difference between the Female students (as % of total students) in Congo (Democratic) in 1990 and the Female students (as % of total students) in Mauritius in 1993?
Make the answer very short. -8.09. What is the difference between the Female students (as % of total students) in Sub-Saharan Africa (developing only) in 1990 and the Female students (as % of total students) in Austria in 1994?
Offer a terse response. -3.6. What is the difference between the Female students (as % of total students) of Sub-Saharan Africa (developing only) in 1990 and the Female students (as % of total students) of Congo (Democratic) in 1994?
Give a very brief answer. 2.42. What is the difference between the Female students (as % of total students) in Sub-Saharan Africa (developing only) in 1990 and the Female students (as % of total students) in Mauritius in 1994?
Make the answer very short. -4.31. What is the difference between the Female students (as % of total students) of Austria in 1990 and the Female students (as % of total students) of Congo (Democratic) in 1994?
Provide a succinct answer. 6.12. What is the difference between the Female students (as % of total students) in Austria in 1990 and the Female students (as % of total students) in Mauritius in 1994?
Your response must be concise. -0.61. What is the difference between the Female students (as % of total students) of Congo (Democratic) in 1990 and the Female students (as % of total students) of Mauritius in 1994?
Offer a very short reply. -8.01. What is the difference between the Female students (as % of total students) of Sub-Saharan Africa (developing only) in 1991 and the Female students (as % of total students) of Austria in 1992?
Provide a succinct answer. -3.43. What is the difference between the Female students (as % of total students) in Sub-Saharan Africa (developing only) in 1991 and the Female students (as % of total students) in Congo (Democratic) in 1992?
Make the answer very short. 2.22. What is the difference between the Female students (as % of total students) of Sub-Saharan Africa (developing only) in 1991 and the Female students (as % of total students) of Mauritius in 1992?
Keep it short and to the point. -4.17. What is the difference between the Female students (as % of total students) of Austria in 1991 and the Female students (as % of total students) of Congo (Democratic) in 1992?
Your answer should be compact. 5.74. What is the difference between the Female students (as % of total students) in Austria in 1991 and the Female students (as % of total students) in Mauritius in 1992?
Offer a very short reply. -0.65. What is the difference between the Female students (as % of total students) of Congo (Democratic) in 1991 and the Female students (as % of total students) of Mauritius in 1992?
Provide a succinct answer. -6.75. What is the difference between the Female students (as % of total students) in Sub-Saharan Africa (developing only) in 1991 and the Female students (as % of total students) in Austria in 1993?
Ensure brevity in your answer.  -3.43. What is the difference between the Female students (as % of total students) of Sub-Saharan Africa (developing only) in 1991 and the Female students (as % of total students) of Congo (Democratic) in 1993?
Offer a terse response. 1.63. What is the difference between the Female students (as % of total students) of Sub-Saharan Africa (developing only) in 1991 and the Female students (as % of total students) of Mauritius in 1993?
Give a very brief answer. -4.17. What is the difference between the Female students (as % of total students) in Austria in 1991 and the Female students (as % of total students) in Congo (Democratic) in 1993?
Your response must be concise. 5.15. What is the difference between the Female students (as % of total students) in Austria in 1991 and the Female students (as % of total students) in Mauritius in 1993?
Your response must be concise. -0.65. What is the difference between the Female students (as % of total students) in Congo (Democratic) in 1991 and the Female students (as % of total students) in Mauritius in 1993?
Your answer should be very brief. -6.76. What is the difference between the Female students (as % of total students) of Sub-Saharan Africa (developing only) in 1991 and the Female students (as % of total students) of Austria in 1994?
Your response must be concise. -3.38. What is the difference between the Female students (as % of total students) of Sub-Saharan Africa (developing only) in 1991 and the Female students (as % of total students) of Congo (Democratic) in 1994?
Make the answer very short. 2.63. What is the difference between the Female students (as % of total students) of Sub-Saharan Africa (developing only) in 1991 and the Female students (as % of total students) of Mauritius in 1994?
Give a very brief answer. -4.09. What is the difference between the Female students (as % of total students) of Austria in 1991 and the Female students (as % of total students) of Congo (Democratic) in 1994?
Provide a short and direct response. 6.15. What is the difference between the Female students (as % of total students) of Austria in 1991 and the Female students (as % of total students) of Mauritius in 1994?
Offer a very short reply. -0.57. What is the difference between the Female students (as % of total students) of Congo (Democratic) in 1991 and the Female students (as % of total students) of Mauritius in 1994?
Provide a short and direct response. -6.68. What is the difference between the Female students (as % of total students) of Sub-Saharan Africa (developing only) in 1992 and the Female students (as % of total students) of Austria in 1993?
Keep it short and to the point. -3.27. What is the difference between the Female students (as % of total students) of Sub-Saharan Africa (developing only) in 1992 and the Female students (as % of total students) of Congo (Democratic) in 1993?
Keep it short and to the point. 1.79. What is the difference between the Female students (as % of total students) of Sub-Saharan Africa (developing only) in 1992 and the Female students (as % of total students) of Mauritius in 1993?
Keep it short and to the point. -4.02. What is the difference between the Female students (as % of total students) of Austria in 1992 and the Female students (as % of total students) of Congo (Democratic) in 1993?
Your answer should be compact. 5.06. What is the difference between the Female students (as % of total students) of Austria in 1992 and the Female students (as % of total students) of Mauritius in 1993?
Your response must be concise. -0.74. What is the difference between the Female students (as % of total students) in Congo (Democratic) in 1992 and the Female students (as % of total students) in Mauritius in 1993?
Give a very brief answer. -6.39. What is the difference between the Female students (as % of total students) in Sub-Saharan Africa (developing only) in 1992 and the Female students (as % of total students) in Austria in 1994?
Offer a terse response. -3.23. What is the difference between the Female students (as % of total students) in Sub-Saharan Africa (developing only) in 1992 and the Female students (as % of total students) in Congo (Democratic) in 1994?
Your answer should be very brief. 2.79. What is the difference between the Female students (as % of total students) in Sub-Saharan Africa (developing only) in 1992 and the Female students (as % of total students) in Mauritius in 1994?
Offer a terse response. -3.94. What is the difference between the Female students (as % of total students) in Austria in 1992 and the Female students (as % of total students) in Congo (Democratic) in 1994?
Offer a terse response. 6.06. What is the difference between the Female students (as % of total students) of Austria in 1992 and the Female students (as % of total students) of Mauritius in 1994?
Offer a very short reply. -0.67. What is the difference between the Female students (as % of total students) in Congo (Democratic) in 1992 and the Female students (as % of total students) in Mauritius in 1994?
Offer a very short reply. -6.31. What is the difference between the Female students (as % of total students) of Sub-Saharan Africa (developing only) in 1993 and the Female students (as % of total students) of Austria in 1994?
Your answer should be compact. -3.25. What is the difference between the Female students (as % of total students) of Sub-Saharan Africa (developing only) in 1993 and the Female students (as % of total students) of Congo (Democratic) in 1994?
Your answer should be very brief. 2.77. What is the difference between the Female students (as % of total students) of Sub-Saharan Africa (developing only) in 1993 and the Female students (as % of total students) of Mauritius in 1994?
Make the answer very short. -3.96. What is the difference between the Female students (as % of total students) in Austria in 1993 and the Female students (as % of total students) in Congo (Democratic) in 1994?
Your answer should be very brief. 6.06. What is the difference between the Female students (as % of total students) of Austria in 1993 and the Female students (as % of total students) of Mauritius in 1994?
Give a very brief answer. -0.67. What is the difference between the Female students (as % of total students) of Congo (Democratic) in 1993 and the Female students (as % of total students) of Mauritius in 1994?
Offer a terse response. -5.73. What is the average Female students (as % of total students) in Sub-Saharan Africa (developing only) per year?
Your answer should be very brief. 45.08. What is the average Female students (as % of total students) in Austria per year?
Offer a very short reply. 48.56. What is the average Female students (as % of total students) in Congo (Democratic) per year?
Your answer should be compact. 42.32. What is the average Female students (as % of total students) in Mauritius per year?
Your answer should be very brief. 49.37. In the year 1986, what is the difference between the Female students (as % of total students) in Sub-Saharan Africa (developing only) and Female students (as % of total students) in Austria?
Give a very brief answer. -3.62. In the year 1986, what is the difference between the Female students (as % of total students) of Sub-Saharan Africa (developing only) and Female students (as % of total students) of Congo (Democratic)?
Give a very brief answer. 5.43. In the year 1986, what is the difference between the Female students (as % of total students) in Sub-Saharan Africa (developing only) and Female students (as % of total students) in Mauritius?
Provide a short and direct response. -4.64. In the year 1986, what is the difference between the Female students (as % of total students) in Austria and Female students (as % of total students) in Congo (Democratic)?
Your answer should be very brief. 9.05. In the year 1986, what is the difference between the Female students (as % of total students) of Austria and Female students (as % of total students) of Mauritius?
Offer a very short reply. -1.02. In the year 1986, what is the difference between the Female students (as % of total students) of Congo (Democratic) and Female students (as % of total students) of Mauritius?
Your answer should be compact. -10.07. In the year 1987, what is the difference between the Female students (as % of total students) of Sub-Saharan Africa (developing only) and Female students (as % of total students) of Austria?
Provide a succinct answer. -3.38. In the year 1987, what is the difference between the Female students (as % of total students) of Sub-Saharan Africa (developing only) and Female students (as % of total students) of Congo (Democratic)?
Provide a short and direct response. 1.2. In the year 1987, what is the difference between the Female students (as % of total students) in Sub-Saharan Africa (developing only) and Female students (as % of total students) in Mauritius?
Your answer should be very brief. -4.35. In the year 1987, what is the difference between the Female students (as % of total students) of Austria and Female students (as % of total students) of Congo (Democratic)?
Give a very brief answer. 4.58. In the year 1987, what is the difference between the Female students (as % of total students) of Austria and Female students (as % of total students) of Mauritius?
Offer a terse response. -0.97. In the year 1987, what is the difference between the Female students (as % of total students) in Congo (Democratic) and Female students (as % of total students) in Mauritius?
Give a very brief answer. -5.55. In the year 1988, what is the difference between the Female students (as % of total students) of Sub-Saharan Africa (developing only) and Female students (as % of total students) of Austria?
Your answer should be compact. -3.91. In the year 1988, what is the difference between the Female students (as % of total students) of Sub-Saharan Africa (developing only) and Female students (as % of total students) of Congo (Democratic)?
Provide a short and direct response. 2.16. In the year 1988, what is the difference between the Female students (as % of total students) in Sub-Saharan Africa (developing only) and Female students (as % of total students) in Mauritius?
Ensure brevity in your answer.  -4.85. In the year 1988, what is the difference between the Female students (as % of total students) of Austria and Female students (as % of total students) of Congo (Democratic)?
Offer a very short reply. 6.07. In the year 1988, what is the difference between the Female students (as % of total students) in Austria and Female students (as % of total students) in Mauritius?
Your answer should be very brief. -0.94. In the year 1988, what is the difference between the Female students (as % of total students) in Congo (Democratic) and Female students (as % of total students) in Mauritius?
Your answer should be very brief. -7.01. In the year 1990, what is the difference between the Female students (as % of total students) in Sub-Saharan Africa (developing only) and Female students (as % of total students) in Austria?
Provide a short and direct response. -3.7. In the year 1990, what is the difference between the Female students (as % of total students) in Sub-Saharan Africa (developing only) and Female students (as % of total students) in Congo (Democratic)?
Your answer should be very brief. 3.7. In the year 1990, what is the difference between the Female students (as % of total students) in Sub-Saharan Africa (developing only) and Female students (as % of total students) in Mauritius?
Give a very brief answer. -4.42. In the year 1990, what is the difference between the Female students (as % of total students) in Austria and Female students (as % of total students) in Congo (Democratic)?
Your response must be concise. 7.4. In the year 1990, what is the difference between the Female students (as % of total students) of Austria and Female students (as % of total students) of Mauritius?
Your answer should be very brief. -0.71. In the year 1990, what is the difference between the Female students (as % of total students) in Congo (Democratic) and Female students (as % of total students) in Mauritius?
Provide a short and direct response. -8.11. In the year 1991, what is the difference between the Female students (as % of total students) in Sub-Saharan Africa (developing only) and Female students (as % of total students) in Austria?
Provide a succinct answer. -3.52. In the year 1991, what is the difference between the Female students (as % of total students) in Sub-Saharan Africa (developing only) and Female students (as % of total students) in Congo (Democratic)?
Provide a succinct answer. 2.59. In the year 1991, what is the difference between the Female students (as % of total students) of Sub-Saharan Africa (developing only) and Female students (as % of total students) of Mauritius?
Your answer should be very brief. -4.12. In the year 1991, what is the difference between the Female students (as % of total students) in Austria and Female students (as % of total students) in Congo (Democratic)?
Offer a terse response. 6.1. In the year 1991, what is the difference between the Female students (as % of total students) of Austria and Female students (as % of total students) of Mauritius?
Your response must be concise. -0.6. In the year 1991, what is the difference between the Female students (as % of total students) in Congo (Democratic) and Female students (as % of total students) in Mauritius?
Your answer should be very brief. -6.71. In the year 1992, what is the difference between the Female students (as % of total students) in Sub-Saharan Africa (developing only) and Female students (as % of total students) in Austria?
Keep it short and to the point. -3.27. In the year 1992, what is the difference between the Female students (as % of total students) of Sub-Saharan Africa (developing only) and Female students (as % of total students) of Congo (Democratic)?
Offer a very short reply. 2.37. In the year 1992, what is the difference between the Female students (as % of total students) of Sub-Saharan Africa (developing only) and Female students (as % of total students) of Mauritius?
Make the answer very short. -4.01. In the year 1992, what is the difference between the Female students (as % of total students) in Austria and Female students (as % of total students) in Congo (Democratic)?
Ensure brevity in your answer.  5.64. In the year 1992, what is the difference between the Female students (as % of total students) of Austria and Female students (as % of total students) of Mauritius?
Give a very brief answer. -0.74. In the year 1992, what is the difference between the Female students (as % of total students) of Congo (Democratic) and Female students (as % of total students) of Mauritius?
Keep it short and to the point. -6.38. In the year 1993, what is the difference between the Female students (as % of total students) of Sub-Saharan Africa (developing only) and Female students (as % of total students) of Austria?
Ensure brevity in your answer.  -3.29. In the year 1993, what is the difference between the Female students (as % of total students) of Sub-Saharan Africa (developing only) and Female students (as % of total students) of Congo (Democratic)?
Provide a succinct answer. 1.77. In the year 1993, what is the difference between the Female students (as % of total students) of Sub-Saharan Africa (developing only) and Female students (as % of total students) of Mauritius?
Your answer should be very brief. -4.04. In the year 1993, what is the difference between the Female students (as % of total students) in Austria and Female students (as % of total students) in Congo (Democratic)?
Give a very brief answer. 5.06. In the year 1993, what is the difference between the Female students (as % of total students) of Austria and Female students (as % of total students) of Mauritius?
Your response must be concise. -0.74. In the year 1993, what is the difference between the Female students (as % of total students) of Congo (Democratic) and Female students (as % of total students) of Mauritius?
Your answer should be compact. -5.8. In the year 1994, what is the difference between the Female students (as % of total students) in Sub-Saharan Africa (developing only) and Female students (as % of total students) in Austria?
Make the answer very short. -3.2. In the year 1994, what is the difference between the Female students (as % of total students) in Sub-Saharan Africa (developing only) and Female students (as % of total students) in Congo (Democratic)?
Offer a terse response. 2.82. In the year 1994, what is the difference between the Female students (as % of total students) in Sub-Saharan Africa (developing only) and Female students (as % of total students) in Mauritius?
Make the answer very short. -3.91. In the year 1994, what is the difference between the Female students (as % of total students) in Austria and Female students (as % of total students) in Congo (Democratic)?
Offer a very short reply. 6.02. In the year 1994, what is the difference between the Female students (as % of total students) in Austria and Female students (as % of total students) in Mauritius?
Give a very brief answer. -0.71. In the year 1994, what is the difference between the Female students (as % of total students) in Congo (Democratic) and Female students (as % of total students) in Mauritius?
Give a very brief answer. -6.73. What is the ratio of the Female students (as % of total students) of Austria in 1986 to that in 1987?
Your answer should be compact. 1. What is the ratio of the Female students (as % of total students) in Congo (Democratic) in 1986 to that in 1987?
Keep it short and to the point. 0.9. What is the ratio of the Female students (as % of total students) of Mauritius in 1986 to that in 1987?
Keep it short and to the point. 1. What is the ratio of the Female students (as % of total students) of Sub-Saharan Africa (developing only) in 1986 to that in 1988?
Your answer should be very brief. 1. What is the ratio of the Female students (as % of total students) of Congo (Democratic) in 1986 to that in 1988?
Make the answer very short. 0.93. What is the ratio of the Female students (as % of total students) of Congo (Democratic) in 1986 to that in 1990?
Your answer should be compact. 0.95. What is the ratio of the Female students (as % of total students) in Sub-Saharan Africa (developing only) in 1986 to that in 1991?
Give a very brief answer. 0.99. What is the ratio of the Female students (as % of total students) of Austria in 1986 to that in 1991?
Give a very brief answer. 0.99. What is the ratio of the Female students (as % of total students) in Congo (Democratic) in 1986 to that in 1991?
Ensure brevity in your answer.  0.92. What is the ratio of the Female students (as % of total students) in Sub-Saharan Africa (developing only) in 1986 to that in 1992?
Provide a short and direct response. 0.99. What is the ratio of the Female students (as % of total students) of Austria in 1986 to that in 1992?
Make the answer very short. 0.99. What is the ratio of the Female students (as % of total students) in Congo (Democratic) in 1986 to that in 1992?
Ensure brevity in your answer.  0.91. What is the ratio of the Female students (as % of total students) in Mauritius in 1986 to that in 1992?
Your response must be concise. 1. What is the ratio of the Female students (as % of total students) of Sub-Saharan Africa (developing only) in 1986 to that in 1993?
Give a very brief answer. 0.99. What is the ratio of the Female students (as % of total students) of Austria in 1986 to that in 1993?
Your response must be concise. 0.99. What is the ratio of the Female students (as % of total students) of Congo (Democratic) in 1986 to that in 1993?
Offer a terse response. 0.9. What is the ratio of the Female students (as % of total students) of Mauritius in 1986 to that in 1993?
Offer a very short reply. 1. What is the ratio of the Female students (as % of total students) in Sub-Saharan Africa (developing only) in 1986 to that in 1994?
Make the answer very short. 0.98. What is the ratio of the Female students (as % of total students) in Austria in 1986 to that in 1994?
Provide a succinct answer. 0.99. What is the ratio of the Female students (as % of total students) of Congo (Democratic) in 1986 to that in 1994?
Ensure brevity in your answer.  0.92. What is the ratio of the Female students (as % of total students) in Mauritius in 1986 to that in 1994?
Provide a short and direct response. 1. What is the ratio of the Female students (as % of total students) in Sub-Saharan Africa (developing only) in 1987 to that in 1988?
Provide a succinct answer. 1.01. What is the ratio of the Female students (as % of total students) of Congo (Democratic) in 1987 to that in 1988?
Offer a terse response. 1.04. What is the ratio of the Female students (as % of total students) of Mauritius in 1987 to that in 1988?
Ensure brevity in your answer.  1. What is the ratio of the Female students (as % of total students) in Sub-Saharan Africa (developing only) in 1987 to that in 1990?
Offer a terse response. 1. What is the ratio of the Female students (as % of total students) in Austria in 1987 to that in 1990?
Your answer should be very brief. 0.99. What is the ratio of the Female students (as % of total students) in Congo (Democratic) in 1987 to that in 1990?
Your response must be concise. 1.06. What is the ratio of the Female students (as % of total students) of Sub-Saharan Africa (developing only) in 1987 to that in 1991?
Make the answer very short. 1. What is the ratio of the Female students (as % of total students) in Congo (Democratic) in 1987 to that in 1991?
Provide a short and direct response. 1.03. What is the ratio of the Female students (as % of total students) in Sub-Saharan Africa (developing only) in 1987 to that in 1992?
Make the answer very short. 0.99. What is the ratio of the Female students (as % of total students) in Sub-Saharan Africa (developing only) in 1987 to that in 1994?
Ensure brevity in your answer.  0.99. What is the ratio of the Female students (as % of total students) in Austria in 1987 to that in 1994?
Your answer should be compact. 1. What is the ratio of the Female students (as % of total students) in Congo (Democratic) in 1987 to that in 1994?
Offer a very short reply. 1.03. What is the ratio of the Female students (as % of total students) in Sub-Saharan Africa (developing only) in 1988 to that in 1990?
Your answer should be very brief. 0.99. What is the ratio of the Female students (as % of total students) in Congo (Democratic) in 1988 to that in 1990?
Your answer should be compact. 1.03. What is the ratio of the Female students (as % of total students) in Mauritius in 1988 to that in 1990?
Offer a terse response. 1. What is the ratio of the Female students (as % of total students) in Sub-Saharan Africa (developing only) in 1988 to that in 1991?
Offer a very short reply. 0.98. What is the ratio of the Female students (as % of total students) in Austria in 1988 to that in 1991?
Give a very brief answer. 0.99. What is the ratio of the Female students (as % of total students) of Mauritius in 1988 to that in 1991?
Give a very brief answer. 1. What is the ratio of the Female students (as % of total students) of Sub-Saharan Africa (developing only) in 1988 to that in 1993?
Provide a short and direct response. 0.98. What is the ratio of the Female students (as % of total students) in Congo (Democratic) in 1988 to that in 1993?
Your answer should be very brief. 0.97. What is the ratio of the Female students (as % of total students) in Mauritius in 1988 to that in 1993?
Offer a terse response. 1. What is the ratio of the Female students (as % of total students) of Sub-Saharan Africa (developing only) in 1988 to that in 1994?
Offer a very short reply. 0.98. What is the ratio of the Female students (as % of total students) in Mauritius in 1988 to that in 1994?
Make the answer very short. 1. What is the ratio of the Female students (as % of total students) of Congo (Democratic) in 1990 to that in 1991?
Offer a terse response. 0.97. What is the ratio of the Female students (as % of total students) of Mauritius in 1990 to that in 1991?
Make the answer very short. 1. What is the ratio of the Female students (as % of total students) in Congo (Democratic) in 1990 to that in 1992?
Your answer should be very brief. 0.96. What is the ratio of the Female students (as % of total students) in Mauritius in 1990 to that in 1992?
Make the answer very short. 1. What is the ratio of the Female students (as % of total students) in Sub-Saharan Africa (developing only) in 1990 to that in 1993?
Your answer should be very brief. 0.99. What is the ratio of the Female students (as % of total students) in Austria in 1990 to that in 1993?
Your response must be concise. 1. What is the ratio of the Female students (as % of total students) of Congo (Democratic) in 1990 to that in 1993?
Your response must be concise. 0.95. What is the ratio of the Female students (as % of total students) of Mauritius in 1990 to that in 1993?
Offer a terse response. 1. What is the ratio of the Female students (as % of total students) of Sub-Saharan Africa (developing only) in 1990 to that in 1994?
Provide a succinct answer. 0.99. What is the ratio of the Female students (as % of total students) in Congo (Democratic) in 1990 to that in 1994?
Your response must be concise. 0.97. What is the ratio of the Female students (as % of total students) of Mauritius in 1990 to that in 1994?
Ensure brevity in your answer.  1. What is the ratio of the Female students (as % of total students) of Congo (Democratic) in 1991 to that in 1992?
Offer a terse response. 0.99. What is the ratio of the Female students (as % of total students) in Sub-Saharan Africa (developing only) in 1991 to that in 1993?
Provide a short and direct response. 1. What is the ratio of the Female students (as % of total students) in Austria in 1991 to that in 1993?
Offer a very short reply. 1. What is the ratio of the Female students (as % of total students) of Congo (Democratic) in 1991 to that in 1993?
Keep it short and to the point. 0.98. What is the ratio of the Female students (as % of total students) of Austria in 1991 to that in 1994?
Provide a short and direct response. 1. What is the ratio of the Female students (as % of total students) of Sub-Saharan Africa (developing only) in 1992 to that in 1993?
Provide a short and direct response. 1. What is the ratio of the Female students (as % of total students) in Congo (Democratic) in 1992 to that in 1993?
Provide a short and direct response. 0.99. What is the ratio of the Female students (as % of total students) in Austria in 1992 to that in 1994?
Give a very brief answer. 1. What is the ratio of the Female students (as % of total students) in Congo (Democratic) in 1992 to that in 1994?
Provide a short and direct response. 1.01. What is the ratio of the Female students (as % of total students) of Mauritius in 1992 to that in 1994?
Make the answer very short. 1. What is the ratio of the Female students (as % of total students) of Congo (Democratic) in 1993 to that in 1994?
Keep it short and to the point. 1.02. What is the difference between the highest and the second highest Female students (as % of total students) of Sub-Saharan Africa (developing only)?
Provide a short and direct response. 0.03. What is the difference between the highest and the second highest Female students (as % of total students) in Austria?
Offer a very short reply. 0.03. What is the difference between the highest and the second highest Female students (as % of total students) of Congo (Democratic)?
Offer a very short reply. 0.27. What is the difference between the highest and the second highest Female students (as % of total students) in Mauritius?
Your answer should be very brief. 0. What is the difference between the highest and the lowest Female students (as % of total students) of Sub-Saharan Africa (developing only)?
Keep it short and to the point. 0.89. What is the difference between the highest and the lowest Female students (as % of total students) in Austria?
Keep it short and to the point. 0.4. What is the difference between the highest and the lowest Female students (as % of total students) in Congo (Democratic)?
Provide a succinct answer. 4.57. What is the difference between the highest and the lowest Female students (as % of total students) of Mauritius?
Keep it short and to the point. 0.1. 